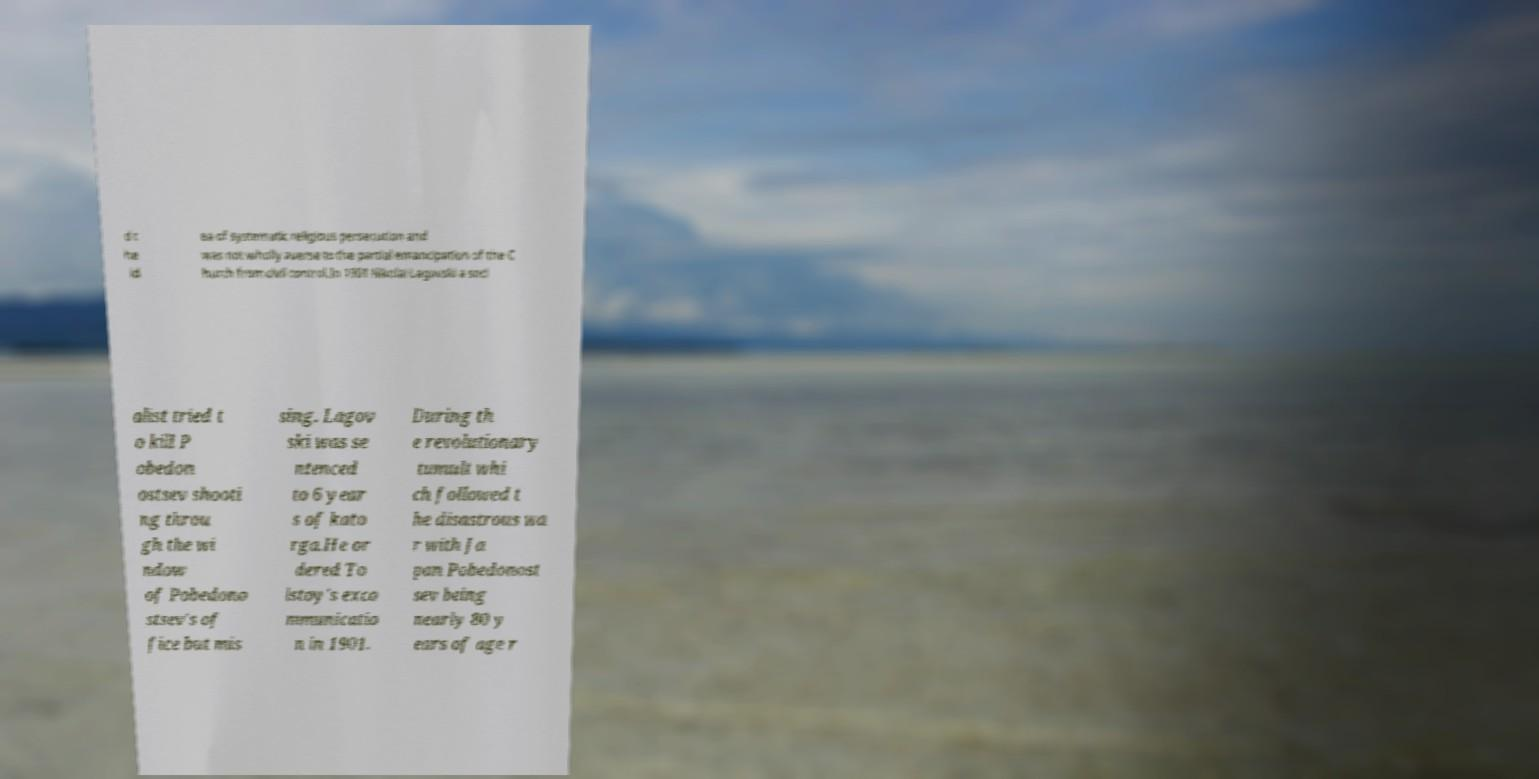There's text embedded in this image that I need extracted. Can you transcribe it verbatim? d t he id ea of systematic religious persecution and was not wholly averse to the partial emancipation of the C hurch from civil control.In 1901 Nikolai Lagovski a soci alist tried t o kill P obedon ostsev shooti ng throu gh the wi ndow of Pobedono stsev's of fice but mis sing. Lagov ski was se ntenced to 6 year s of kato rga.He or dered To lstoy's exco mmunicatio n in 1901. During th e revolutionary tumult whi ch followed t he disastrous wa r with Ja pan Pobedonost sev being nearly 80 y ears of age r 